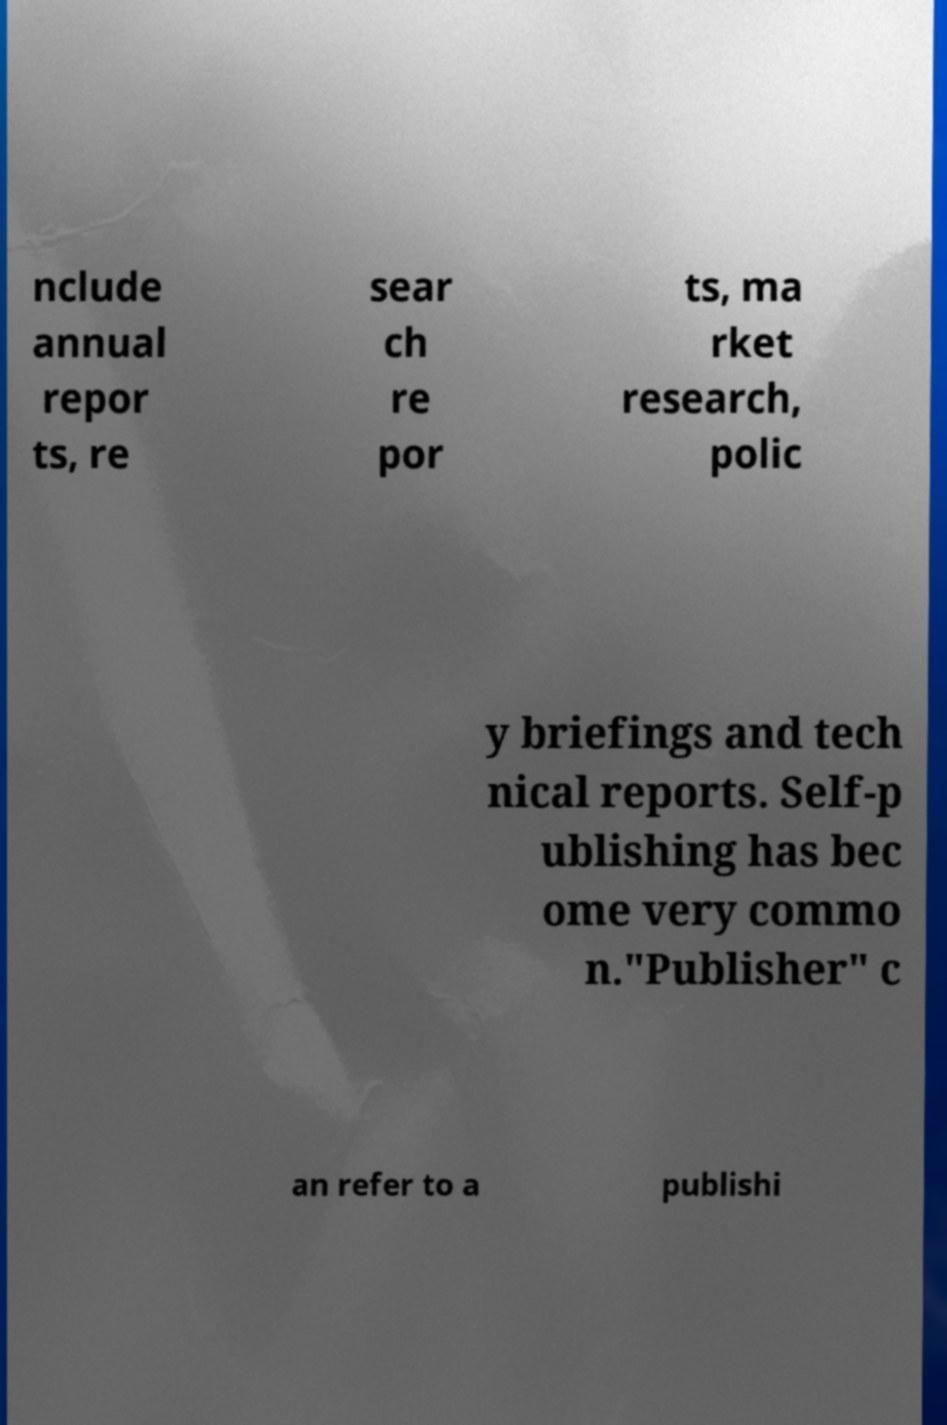I need the written content from this picture converted into text. Can you do that? nclude annual repor ts, re sear ch re por ts, ma rket research, polic y briefings and tech nical reports. Self-p ublishing has bec ome very commo n."Publisher" c an refer to a publishi 